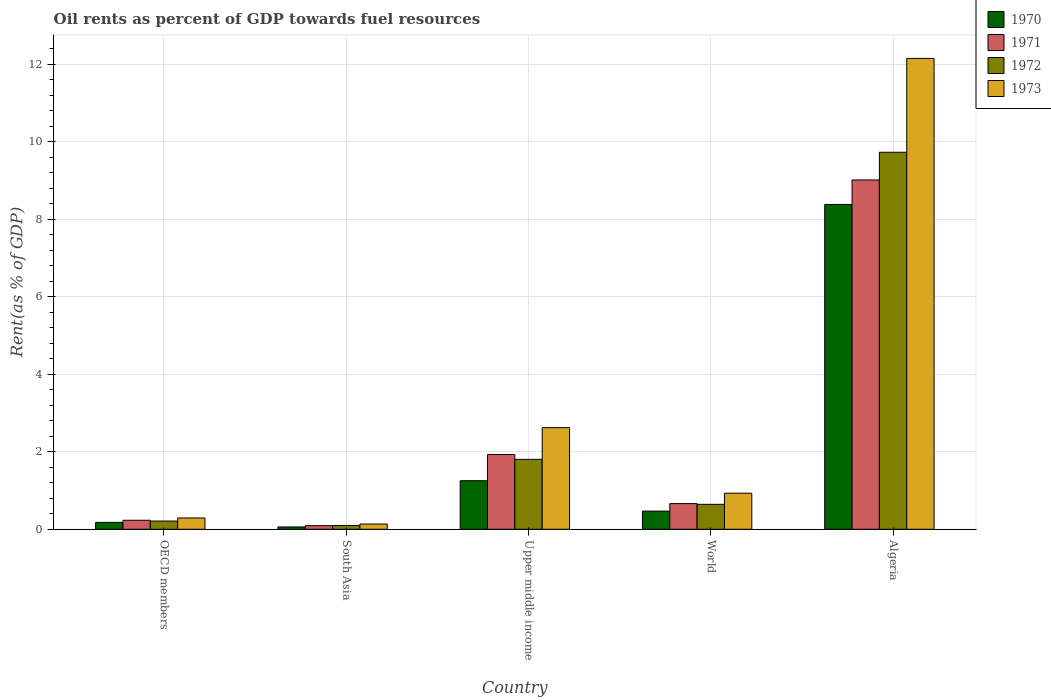How many different coloured bars are there?
Your answer should be very brief. 4. How many groups of bars are there?
Your answer should be very brief. 5. Are the number of bars on each tick of the X-axis equal?
Your response must be concise. Yes. How many bars are there on the 5th tick from the right?
Your response must be concise. 4. What is the label of the 2nd group of bars from the left?
Provide a succinct answer. South Asia. What is the oil rent in 1972 in World?
Offer a very short reply. 0.64. Across all countries, what is the maximum oil rent in 1973?
Ensure brevity in your answer.  12.15. Across all countries, what is the minimum oil rent in 1970?
Your answer should be compact. 0.06. In which country was the oil rent in 1972 maximum?
Provide a succinct answer. Algeria. What is the total oil rent in 1970 in the graph?
Give a very brief answer. 10.34. What is the difference between the oil rent in 1971 in South Asia and that in Upper middle income?
Your answer should be compact. -1.84. What is the difference between the oil rent in 1972 in Algeria and the oil rent in 1970 in OECD members?
Ensure brevity in your answer.  9.55. What is the average oil rent in 1972 per country?
Your answer should be very brief. 2.5. What is the difference between the oil rent of/in 1972 and oil rent of/in 1970 in OECD members?
Your response must be concise. 0.03. In how many countries, is the oil rent in 1972 greater than 1.6 %?
Your answer should be compact. 2. What is the ratio of the oil rent in 1973 in Algeria to that in South Asia?
Make the answer very short. 89.99. Is the oil rent in 1973 in OECD members less than that in South Asia?
Provide a succinct answer. No. What is the difference between the highest and the second highest oil rent in 1973?
Your answer should be compact. -1.69. What is the difference between the highest and the lowest oil rent in 1970?
Your answer should be very brief. 8.32. In how many countries, is the oil rent in 1973 greater than the average oil rent in 1973 taken over all countries?
Your response must be concise. 1. Is the sum of the oil rent in 1971 in South Asia and Upper middle income greater than the maximum oil rent in 1970 across all countries?
Keep it short and to the point. No. What does the 4th bar from the left in OECD members represents?
Your answer should be very brief. 1973. Is it the case that in every country, the sum of the oil rent in 1973 and oil rent in 1970 is greater than the oil rent in 1971?
Make the answer very short. Yes. Are all the bars in the graph horizontal?
Make the answer very short. No. How many countries are there in the graph?
Provide a succinct answer. 5. What is the difference between two consecutive major ticks on the Y-axis?
Offer a terse response. 2. Does the graph contain grids?
Make the answer very short. Yes. How many legend labels are there?
Keep it short and to the point. 4. What is the title of the graph?
Your answer should be compact. Oil rents as percent of GDP towards fuel resources. What is the label or title of the Y-axis?
Your answer should be compact. Rent(as % of GDP). What is the Rent(as % of GDP) in 1970 in OECD members?
Your response must be concise. 0.18. What is the Rent(as % of GDP) of 1971 in OECD members?
Keep it short and to the point. 0.23. What is the Rent(as % of GDP) in 1972 in OECD members?
Keep it short and to the point. 0.21. What is the Rent(as % of GDP) of 1973 in OECD members?
Your answer should be very brief. 0.29. What is the Rent(as % of GDP) in 1970 in South Asia?
Your answer should be very brief. 0.06. What is the Rent(as % of GDP) in 1971 in South Asia?
Provide a short and direct response. 0.09. What is the Rent(as % of GDP) in 1972 in South Asia?
Provide a short and direct response. 0.1. What is the Rent(as % of GDP) in 1973 in South Asia?
Keep it short and to the point. 0.14. What is the Rent(as % of GDP) in 1970 in Upper middle income?
Offer a terse response. 1.25. What is the Rent(as % of GDP) in 1971 in Upper middle income?
Ensure brevity in your answer.  1.93. What is the Rent(as % of GDP) in 1972 in Upper middle income?
Ensure brevity in your answer.  1.8. What is the Rent(as % of GDP) in 1973 in Upper middle income?
Provide a succinct answer. 2.62. What is the Rent(as % of GDP) of 1970 in World?
Offer a very short reply. 0.47. What is the Rent(as % of GDP) in 1971 in World?
Provide a short and direct response. 0.66. What is the Rent(as % of GDP) of 1972 in World?
Offer a terse response. 0.64. What is the Rent(as % of GDP) in 1973 in World?
Your answer should be very brief. 0.93. What is the Rent(as % of GDP) in 1970 in Algeria?
Offer a terse response. 8.38. What is the Rent(as % of GDP) of 1971 in Algeria?
Make the answer very short. 9.02. What is the Rent(as % of GDP) of 1972 in Algeria?
Offer a very short reply. 9.73. What is the Rent(as % of GDP) of 1973 in Algeria?
Your answer should be very brief. 12.15. Across all countries, what is the maximum Rent(as % of GDP) of 1970?
Offer a terse response. 8.38. Across all countries, what is the maximum Rent(as % of GDP) of 1971?
Give a very brief answer. 9.02. Across all countries, what is the maximum Rent(as % of GDP) of 1972?
Keep it short and to the point. 9.73. Across all countries, what is the maximum Rent(as % of GDP) of 1973?
Make the answer very short. 12.15. Across all countries, what is the minimum Rent(as % of GDP) in 1970?
Offer a terse response. 0.06. Across all countries, what is the minimum Rent(as % of GDP) in 1971?
Give a very brief answer. 0.09. Across all countries, what is the minimum Rent(as % of GDP) of 1972?
Give a very brief answer. 0.1. Across all countries, what is the minimum Rent(as % of GDP) of 1973?
Offer a terse response. 0.14. What is the total Rent(as % of GDP) in 1970 in the graph?
Offer a very short reply. 10.34. What is the total Rent(as % of GDP) of 1971 in the graph?
Offer a very short reply. 11.93. What is the total Rent(as % of GDP) in 1972 in the graph?
Your response must be concise. 12.49. What is the total Rent(as % of GDP) in 1973 in the graph?
Give a very brief answer. 16.13. What is the difference between the Rent(as % of GDP) of 1970 in OECD members and that in South Asia?
Provide a short and direct response. 0.12. What is the difference between the Rent(as % of GDP) of 1971 in OECD members and that in South Asia?
Offer a very short reply. 0.14. What is the difference between the Rent(as % of GDP) of 1972 in OECD members and that in South Asia?
Give a very brief answer. 0.11. What is the difference between the Rent(as % of GDP) in 1973 in OECD members and that in South Asia?
Offer a terse response. 0.16. What is the difference between the Rent(as % of GDP) in 1970 in OECD members and that in Upper middle income?
Your answer should be compact. -1.08. What is the difference between the Rent(as % of GDP) of 1971 in OECD members and that in Upper middle income?
Ensure brevity in your answer.  -1.7. What is the difference between the Rent(as % of GDP) of 1972 in OECD members and that in Upper middle income?
Your answer should be compact. -1.59. What is the difference between the Rent(as % of GDP) of 1973 in OECD members and that in Upper middle income?
Make the answer very short. -2.33. What is the difference between the Rent(as % of GDP) of 1970 in OECD members and that in World?
Your response must be concise. -0.29. What is the difference between the Rent(as % of GDP) of 1971 in OECD members and that in World?
Provide a short and direct response. -0.43. What is the difference between the Rent(as % of GDP) in 1972 in OECD members and that in World?
Keep it short and to the point. -0.43. What is the difference between the Rent(as % of GDP) of 1973 in OECD members and that in World?
Ensure brevity in your answer.  -0.64. What is the difference between the Rent(as % of GDP) of 1970 in OECD members and that in Algeria?
Ensure brevity in your answer.  -8.21. What is the difference between the Rent(as % of GDP) in 1971 in OECD members and that in Algeria?
Keep it short and to the point. -8.78. What is the difference between the Rent(as % of GDP) in 1972 in OECD members and that in Algeria?
Offer a very short reply. -9.52. What is the difference between the Rent(as % of GDP) in 1973 in OECD members and that in Algeria?
Your answer should be very brief. -11.86. What is the difference between the Rent(as % of GDP) in 1970 in South Asia and that in Upper middle income?
Keep it short and to the point. -1.19. What is the difference between the Rent(as % of GDP) in 1971 in South Asia and that in Upper middle income?
Provide a succinct answer. -1.84. What is the difference between the Rent(as % of GDP) of 1972 in South Asia and that in Upper middle income?
Provide a short and direct response. -1.71. What is the difference between the Rent(as % of GDP) of 1973 in South Asia and that in Upper middle income?
Your answer should be very brief. -2.49. What is the difference between the Rent(as % of GDP) of 1970 in South Asia and that in World?
Give a very brief answer. -0.41. What is the difference between the Rent(as % of GDP) of 1971 in South Asia and that in World?
Keep it short and to the point. -0.57. What is the difference between the Rent(as % of GDP) in 1972 in South Asia and that in World?
Ensure brevity in your answer.  -0.55. What is the difference between the Rent(as % of GDP) in 1973 in South Asia and that in World?
Your answer should be very brief. -0.8. What is the difference between the Rent(as % of GDP) in 1970 in South Asia and that in Algeria?
Offer a very short reply. -8.32. What is the difference between the Rent(as % of GDP) of 1971 in South Asia and that in Algeria?
Provide a short and direct response. -8.92. What is the difference between the Rent(as % of GDP) of 1972 in South Asia and that in Algeria?
Your answer should be compact. -9.63. What is the difference between the Rent(as % of GDP) in 1973 in South Asia and that in Algeria?
Keep it short and to the point. -12.02. What is the difference between the Rent(as % of GDP) of 1970 in Upper middle income and that in World?
Ensure brevity in your answer.  0.78. What is the difference between the Rent(as % of GDP) of 1971 in Upper middle income and that in World?
Your answer should be very brief. 1.27. What is the difference between the Rent(as % of GDP) in 1972 in Upper middle income and that in World?
Keep it short and to the point. 1.16. What is the difference between the Rent(as % of GDP) in 1973 in Upper middle income and that in World?
Offer a very short reply. 1.69. What is the difference between the Rent(as % of GDP) of 1970 in Upper middle income and that in Algeria?
Provide a succinct answer. -7.13. What is the difference between the Rent(as % of GDP) in 1971 in Upper middle income and that in Algeria?
Your answer should be very brief. -7.09. What is the difference between the Rent(as % of GDP) in 1972 in Upper middle income and that in Algeria?
Your answer should be very brief. -7.93. What is the difference between the Rent(as % of GDP) of 1973 in Upper middle income and that in Algeria?
Keep it short and to the point. -9.53. What is the difference between the Rent(as % of GDP) in 1970 in World and that in Algeria?
Offer a terse response. -7.91. What is the difference between the Rent(as % of GDP) in 1971 in World and that in Algeria?
Offer a very short reply. -8.35. What is the difference between the Rent(as % of GDP) in 1972 in World and that in Algeria?
Keep it short and to the point. -9.09. What is the difference between the Rent(as % of GDP) in 1973 in World and that in Algeria?
Your answer should be very brief. -11.22. What is the difference between the Rent(as % of GDP) in 1970 in OECD members and the Rent(as % of GDP) in 1971 in South Asia?
Your response must be concise. 0.08. What is the difference between the Rent(as % of GDP) of 1970 in OECD members and the Rent(as % of GDP) of 1972 in South Asia?
Provide a succinct answer. 0.08. What is the difference between the Rent(as % of GDP) of 1970 in OECD members and the Rent(as % of GDP) of 1973 in South Asia?
Your answer should be very brief. 0.04. What is the difference between the Rent(as % of GDP) in 1971 in OECD members and the Rent(as % of GDP) in 1972 in South Asia?
Your answer should be compact. 0.13. What is the difference between the Rent(as % of GDP) in 1971 in OECD members and the Rent(as % of GDP) in 1973 in South Asia?
Make the answer very short. 0.1. What is the difference between the Rent(as % of GDP) of 1972 in OECD members and the Rent(as % of GDP) of 1973 in South Asia?
Give a very brief answer. 0.08. What is the difference between the Rent(as % of GDP) in 1970 in OECD members and the Rent(as % of GDP) in 1971 in Upper middle income?
Your response must be concise. -1.75. What is the difference between the Rent(as % of GDP) of 1970 in OECD members and the Rent(as % of GDP) of 1972 in Upper middle income?
Keep it short and to the point. -1.63. What is the difference between the Rent(as % of GDP) of 1970 in OECD members and the Rent(as % of GDP) of 1973 in Upper middle income?
Offer a terse response. -2.44. What is the difference between the Rent(as % of GDP) in 1971 in OECD members and the Rent(as % of GDP) in 1972 in Upper middle income?
Make the answer very short. -1.57. What is the difference between the Rent(as % of GDP) of 1971 in OECD members and the Rent(as % of GDP) of 1973 in Upper middle income?
Give a very brief answer. -2.39. What is the difference between the Rent(as % of GDP) of 1972 in OECD members and the Rent(as % of GDP) of 1973 in Upper middle income?
Provide a succinct answer. -2.41. What is the difference between the Rent(as % of GDP) in 1970 in OECD members and the Rent(as % of GDP) in 1971 in World?
Your response must be concise. -0.48. What is the difference between the Rent(as % of GDP) of 1970 in OECD members and the Rent(as % of GDP) of 1972 in World?
Your answer should be very brief. -0.47. What is the difference between the Rent(as % of GDP) in 1970 in OECD members and the Rent(as % of GDP) in 1973 in World?
Your answer should be very brief. -0.75. What is the difference between the Rent(as % of GDP) in 1971 in OECD members and the Rent(as % of GDP) in 1972 in World?
Keep it short and to the point. -0.41. What is the difference between the Rent(as % of GDP) of 1971 in OECD members and the Rent(as % of GDP) of 1973 in World?
Provide a short and direct response. -0.7. What is the difference between the Rent(as % of GDP) in 1972 in OECD members and the Rent(as % of GDP) in 1973 in World?
Keep it short and to the point. -0.72. What is the difference between the Rent(as % of GDP) of 1970 in OECD members and the Rent(as % of GDP) of 1971 in Algeria?
Provide a short and direct response. -8.84. What is the difference between the Rent(as % of GDP) of 1970 in OECD members and the Rent(as % of GDP) of 1972 in Algeria?
Provide a short and direct response. -9.55. What is the difference between the Rent(as % of GDP) of 1970 in OECD members and the Rent(as % of GDP) of 1973 in Algeria?
Your answer should be very brief. -11.97. What is the difference between the Rent(as % of GDP) in 1971 in OECD members and the Rent(as % of GDP) in 1972 in Algeria?
Your answer should be compact. -9.5. What is the difference between the Rent(as % of GDP) of 1971 in OECD members and the Rent(as % of GDP) of 1973 in Algeria?
Make the answer very short. -11.92. What is the difference between the Rent(as % of GDP) of 1972 in OECD members and the Rent(as % of GDP) of 1973 in Algeria?
Your answer should be very brief. -11.94. What is the difference between the Rent(as % of GDP) in 1970 in South Asia and the Rent(as % of GDP) in 1971 in Upper middle income?
Give a very brief answer. -1.87. What is the difference between the Rent(as % of GDP) in 1970 in South Asia and the Rent(as % of GDP) in 1972 in Upper middle income?
Make the answer very short. -1.74. What is the difference between the Rent(as % of GDP) in 1970 in South Asia and the Rent(as % of GDP) in 1973 in Upper middle income?
Offer a terse response. -2.56. What is the difference between the Rent(as % of GDP) of 1971 in South Asia and the Rent(as % of GDP) of 1972 in Upper middle income?
Give a very brief answer. -1.71. What is the difference between the Rent(as % of GDP) in 1971 in South Asia and the Rent(as % of GDP) in 1973 in Upper middle income?
Provide a succinct answer. -2.53. What is the difference between the Rent(as % of GDP) of 1972 in South Asia and the Rent(as % of GDP) of 1973 in Upper middle income?
Your answer should be compact. -2.52. What is the difference between the Rent(as % of GDP) in 1970 in South Asia and the Rent(as % of GDP) in 1971 in World?
Your response must be concise. -0.6. What is the difference between the Rent(as % of GDP) in 1970 in South Asia and the Rent(as % of GDP) in 1972 in World?
Give a very brief answer. -0.58. What is the difference between the Rent(as % of GDP) of 1970 in South Asia and the Rent(as % of GDP) of 1973 in World?
Provide a succinct answer. -0.87. What is the difference between the Rent(as % of GDP) in 1971 in South Asia and the Rent(as % of GDP) in 1972 in World?
Your response must be concise. -0.55. What is the difference between the Rent(as % of GDP) in 1971 in South Asia and the Rent(as % of GDP) in 1973 in World?
Make the answer very short. -0.84. What is the difference between the Rent(as % of GDP) of 1972 in South Asia and the Rent(as % of GDP) of 1973 in World?
Ensure brevity in your answer.  -0.83. What is the difference between the Rent(as % of GDP) of 1970 in South Asia and the Rent(as % of GDP) of 1971 in Algeria?
Ensure brevity in your answer.  -8.96. What is the difference between the Rent(as % of GDP) of 1970 in South Asia and the Rent(as % of GDP) of 1972 in Algeria?
Your answer should be compact. -9.67. What is the difference between the Rent(as % of GDP) in 1970 in South Asia and the Rent(as % of GDP) in 1973 in Algeria?
Provide a short and direct response. -12.09. What is the difference between the Rent(as % of GDP) of 1971 in South Asia and the Rent(as % of GDP) of 1972 in Algeria?
Give a very brief answer. -9.64. What is the difference between the Rent(as % of GDP) in 1971 in South Asia and the Rent(as % of GDP) in 1973 in Algeria?
Provide a succinct answer. -12.06. What is the difference between the Rent(as % of GDP) of 1972 in South Asia and the Rent(as % of GDP) of 1973 in Algeria?
Provide a short and direct response. -12.05. What is the difference between the Rent(as % of GDP) of 1970 in Upper middle income and the Rent(as % of GDP) of 1971 in World?
Provide a short and direct response. 0.59. What is the difference between the Rent(as % of GDP) of 1970 in Upper middle income and the Rent(as % of GDP) of 1972 in World?
Provide a short and direct response. 0.61. What is the difference between the Rent(as % of GDP) in 1970 in Upper middle income and the Rent(as % of GDP) in 1973 in World?
Provide a succinct answer. 0.32. What is the difference between the Rent(as % of GDP) in 1971 in Upper middle income and the Rent(as % of GDP) in 1972 in World?
Keep it short and to the point. 1.29. What is the difference between the Rent(as % of GDP) in 1972 in Upper middle income and the Rent(as % of GDP) in 1973 in World?
Your answer should be compact. 0.87. What is the difference between the Rent(as % of GDP) of 1970 in Upper middle income and the Rent(as % of GDP) of 1971 in Algeria?
Make the answer very short. -7.76. What is the difference between the Rent(as % of GDP) in 1970 in Upper middle income and the Rent(as % of GDP) in 1972 in Algeria?
Keep it short and to the point. -8.48. What is the difference between the Rent(as % of GDP) of 1970 in Upper middle income and the Rent(as % of GDP) of 1973 in Algeria?
Give a very brief answer. -10.9. What is the difference between the Rent(as % of GDP) in 1971 in Upper middle income and the Rent(as % of GDP) in 1972 in Algeria?
Give a very brief answer. -7.8. What is the difference between the Rent(as % of GDP) of 1971 in Upper middle income and the Rent(as % of GDP) of 1973 in Algeria?
Keep it short and to the point. -10.22. What is the difference between the Rent(as % of GDP) of 1972 in Upper middle income and the Rent(as % of GDP) of 1973 in Algeria?
Keep it short and to the point. -10.35. What is the difference between the Rent(as % of GDP) of 1970 in World and the Rent(as % of GDP) of 1971 in Algeria?
Your answer should be very brief. -8.55. What is the difference between the Rent(as % of GDP) in 1970 in World and the Rent(as % of GDP) in 1972 in Algeria?
Give a very brief answer. -9.26. What is the difference between the Rent(as % of GDP) in 1970 in World and the Rent(as % of GDP) in 1973 in Algeria?
Offer a terse response. -11.68. What is the difference between the Rent(as % of GDP) in 1971 in World and the Rent(as % of GDP) in 1972 in Algeria?
Keep it short and to the point. -9.07. What is the difference between the Rent(as % of GDP) of 1971 in World and the Rent(as % of GDP) of 1973 in Algeria?
Keep it short and to the point. -11.49. What is the difference between the Rent(as % of GDP) in 1972 in World and the Rent(as % of GDP) in 1973 in Algeria?
Provide a short and direct response. -11.51. What is the average Rent(as % of GDP) of 1970 per country?
Provide a succinct answer. 2.07. What is the average Rent(as % of GDP) in 1971 per country?
Give a very brief answer. 2.39. What is the average Rent(as % of GDP) of 1972 per country?
Make the answer very short. 2.5. What is the average Rent(as % of GDP) in 1973 per country?
Your response must be concise. 3.23. What is the difference between the Rent(as % of GDP) of 1970 and Rent(as % of GDP) of 1971 in OECD members?
Your answer should be compact. -0.05. What is the difference between the Rent(as % of GDP) in 1970 and Rent(as % of GDP) in 1972 in OECD members?
Your answer should be very brief. -0.03. What is the difference between the Rent(as % of GDP) in 1970 and Rent(as % of GDP) in 1973 in OECD members?
Offer a very short reply. -0.11. What is the difference between the Rent(as % of GDP) in 1971 and Rent(as % of GDP) in 1972 in OECD members?
Your response must be concise. 0.02. What is the difference between the Rent(as % of GDP) in 1971 and Rent(as % of GDP) in 1973 in OECD members?
Your answer should be compact. -0.06. What is the difference between the Rent(as % of GDP) in 1972 and Rent(as % of GDP) in 1973 in OECD members?
Keep it short and to the point. -0.08. What is the difference between the Rent(as % of GDP) in 1970 and Rent(as % of GDP) in 1971 in South Asia?
Keep it short and to the point. -0.03. What is the difference between the Rent(as % of GDP) of 1970 and Rent(as % of GDP) of 1972 in South Asia?
Offer a very short reply. -0.04. What is the difference between the Rent(as % of GDP) of 1970 and Rent(as % of GDP) of 1973 in South Asia?
Keep it short and to the point. -0.08. What is the difference between the Rent(as % of GDP) of 1971 and Rent(as % of GDP) of 1972 in South Asia?
Offer a very short reply. -0.01. What is the difference between the Rent(as % of GDP) of 1971 and Rent(as % of GDP) of 1973 in South Asia?
Keep it short and to the point. -0.04. What is the difference between the Rent(as % of GDP) in 1972 and Rent(as % of GDP) in 1973 in South Asia?
Provide a succinct answer. -0.04. What is the difference between the Rent(as % of GDP) in 1970 and Rent(as % of GDP) in 1971 in Upper middle income?
Make the answer very short. -0.68. What is the difference between the Rent(as % of GDP) of 1970 and Rent(as % of GDP) of 1972 in Upper middle income?
Make the answer very short. -0.55. What is the difference between the Rent(as % of GDP) of 1970 and Rent(as % of GDP) of 1973 in Upper middle income?
Provide a short and direct response. -1.37. What is the difference between the Rent(as % of GDP) in 1971 and Rent(as % of GDP) in 1972 in Upper middle income?
Provide a succinct answer. 0.13. What is the difference between the Rent(as % of GDP) in 1971 and Rent(as % of GDP) in 1973 in Upper middle income?
Make the answer very short. -0.69. What is the difference between the Rent(as % of GDP) in 1972 and Rent(as % of GDP) in 1973 in Upper middle income?
Provide a succinct answer. -0.82. What is the difference between the Rent(as % of GDP) in 1970 and Rent(as % of GDP) in 1971 in World?
Offer a very short reply. -0.19. What is the difference between the Rent(as % of GDP) of 1970 and Rent(as % of GDP) of 1972 in World?
Offer a terse response. -0.17. What is the difference between the Rent(as % of GDP) of 1970 and Rent(as % of GDP) of 1973 in World?
Your response must be concise. -0.46. What is the difference between the Rent(as % of GDP) of 1971 and Rent(as % of GDP) of 1972 in World?
Give a very brief answer. 0.02. What is the difference between the Rent(as % of GDP) in 1971 and Rent(as % of GDP) in 1973 in World?
Your response must be concise. -0.27. What is the difference between the Rent(as % of GDP) in 1972 and Rent(as % of GDP) in 1973 in World?
Keep it short and to the point. -0.29. What is the difference between the Rent(as % of GDP) in 1970 and Rent(as % of GDP) in 1971 in Algeria?
Your answer should be compact. -0.63. What is the difference between the Rent(as % of GDP) in 1970 and Rent(as % of GDP) in 1972 in Algeria?
Ensure brevity in your answer.  -1.35. What is the difference between the Rent(as % of GDP) of 1970 and Rent(as % of GDP) of 1973 in Algeria?
Provide a succinct answer. -3.77. What is the difference between the Rent(as % of GDP) of 1971 and Rent(as % of GDP) of 1972 in Algeria?
Make the answer very short. -0.71. What is the difference between the Rent(as % of GDP) of 1971 and Rent(as % of GDP) of 1973 in Algeria?
Keep it short and to the point. -3.14. What is the difference between the Rent(as % of GDP) in 1972 and Rent(as % of GDP) in 1973 in Algeria?
Give a very brief answer. -2.42. What is the ratio of the Rent(as % of GDP) of 1970 in OECD members to that in South Asia?
Ensure brevity in your answer.  2.97. What is the ratio of the Rent(as % of GDP) of 1971 in OECD members to that in South Asia?
Offer a terse response. 2.5. What is the ratio of the Rent(as % of GDP) of 1972 in OECD members to that in South Asia?
Your answer should be compact. 2.15. What is the ratio of the Rent(as % of GDP) of 1973 in OECD members to that in South Asia?
Your response must be concise. 2.16. What is the ratio of the Rent(as % of GDP) in 1970 in OECD members to that in Upper middle income?
Make the answer very short. 0.14. What is the ratio of the Rent(as % of GDP) in 1971 in OECD members to that in Upper middle income?
Offer a terse response. 0.12. What is the ratio of the Rent(as % of GDP) of 1972 in OECD members to that in Upper middle income?
Your answer should be very brief. 0.12. What is the ratio of the Rent(as % of GDP) in 1973 in OECD members to that in Upper middle income?
Offer a very short reply. 0.11. What is the ratio of the Rent(as % of GDP) of 1970 in OECD members to that in World?
Provide a succinct answer. 0.38. What is the ratio of the Rent(as % of GDP) in 1971 in OECD members to that in World?
Provide a succinct answer. 0.35. What is the ratio of the Rent(as % of GDP) of 1972 in OECD members to that in World?
Provide a short and direct response. 0.33. What is the ratio of the Rent(as % of GDP) of 1973 in OECD members to that in World?
Give a very brief answer. 0.31. What is the ratio of the Rent(as % of GDP) in 1970 in OECD members to that in Algeria?
Keep it short and to the point. 0.02. What is the ratio of the Rent(as % of GDP) of 1971 in OECD members to that in Algeria?
Offer a terse response. 0.03. What is the ratio of the Rent(as % of GDP) in 1972 in OECD members to that in Algeria?
Provide a succinct answer. 0.02. What is the ratio of the Rent(as % of GDP) of 1973 in OECD members to that in Algeria?
Provide a short and direct response. 0.02. What is the ratio of the Rent(as % of GDP) of 1970 in South Asia to that in Upper middle income?
Ensure brevity in your answer.  0.05. What is the ratio of the Rent(as % of GDP) of 1971 in South Asia to that in Upper middle income?
Ensure brevity in your answer.  0.05. What is the ratio of the Rent(as % of GDP) of 1972 in South Asia to that in Upper middle income?
Offer a terse response. 0.05. What is the ratio of the Rent(as % of GDP) in 1973 in South Asia to that in Upper middle income?
Keep it short and to the point. 0.05. What is the ratio of the Rent(as % of GDP) in 1970 in South Asia to that in World?
Ensure brevity in your answer.  0.13. What is the ratio of the Rent(as % of GDP) of 1971 in South Asia to that in World?
Give a very brief answer. 0.14. What is the ratio of the Rent(as % of GDP) of 1972 in South Asia to that in World?
Ensure brevity in your answer.  0.15. What is the ratio of the Rent(as % of GDP) in 1973 in South Asia to that in World?
Ensure brevity in your answer.  0.14. What is the ratio of the Rent(as % of GDP) in 1970 in South Asia to that in Algeria?
Ensure brevity in your answer.  0.01. What is the ratio of the Rent(as % of GDP) in 1971 in South Asia to that in Algeria?
Offer a very short reply. 0.01. What is the ratio of the Rent(as % of GDP) of 1972 in South Asia to that in Algeria?
Your answer should be compact. 0.01. What is the ratio of the Rent(as % of GDP) of 1973 in South Asia to that in Algeria?
Ensure brevity in your answer.  0.01. What is the ratio of the Rent(as % of GDP) in 1970 in Upper middle income to that in World?
Provide a succinct answer. 2.67. What is the ratio of the Rent(as % of GDP) of 1971 in Upper middle income to that in World?
Keep it short and to the point. 2.91. What is the ratio of the Rent(as % of GDP) of 1972 in Upper middle income to that in World?
Keep it short and to the point. 2.8. What is the ratio of the Rent(as % of GDP) in 1973 in Upper middle income to that in World?
Provide a short and direct response. 2.82. What is the ratio of the Rent(as % of GDP) of 1970 in Upper middle income to that in Algeria?
Ensure brevity in your answer.  0.15. What is the ratio of the Rent(as % of GDP) in 1971 in Upper middle income to that in Algeria?
Give a very brief answer. 0.21. What is the ratio of the Rent(as % of GDP) of 1972 in Upper middle income to that in Algeria?
Provide a short and direct response. 0.19. What is the ratio of the Rent(as % of GDP) in 1973 in Upper middle income to that in Algeria?
Provide a succinct answer. 0.22. What is the ratio of the Rent(as % of GDP) in 1970 in World to that in Algeria?
Offer a very short reply. 0.06. What is the ratio of the Rent(as % of GDP) in 1971 in World to that in Algeria?
Offer a terse response. 0.07. What is the ratio of the Rent(as % of GDP) in 1972 in World to that in Algeria?
Give a very brief answer. 0.07. What is the ratio of the Rent(as % of GDP) in 1973 in World to that in Algeria?
Keep it short and to the point. 0.08. What is the difference between the highest and the second highest Rent(as % of GDP) in 1970?
Your response must be concise. 7.13. What is the difference between the highest and the second highest Rent(as % of GDP) in 1971?
Your response must be concise. 7.09. What is the difference between the highest and the second highest Rent(as % of GDP) in 1972?
Your answer should be compact. 7.93. What is the difference between the highest and the second highest Rent(as % of GDP) of 1973?
Ensure brevity in your answer.  9.53. What is the difference between the highest and the lowest Rent(as % of GDP) in 1970?
Your response must be concise. 8.32. What is the difference between the highest and the lowest Rent(as % of GDP) in 1971?
Offer a very short reply. 8.92. What is the difference between the highest and the lowest Rent(as % of GDP) in 1972?
Your response must be concise. 9.63. What is the difference between the highest and the lowest Rent(as % of GDP) of 1973?
Your response must be concise. 12.02. 